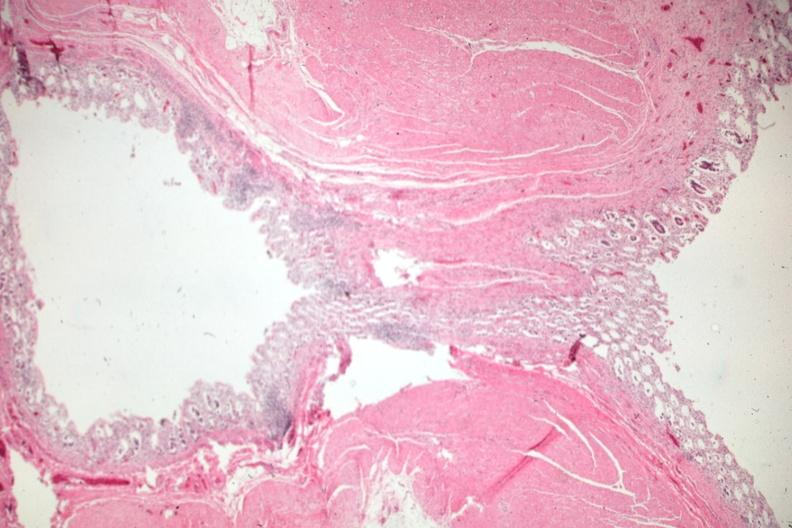what is present?
Answer the question using a single word or phrase. Colon 